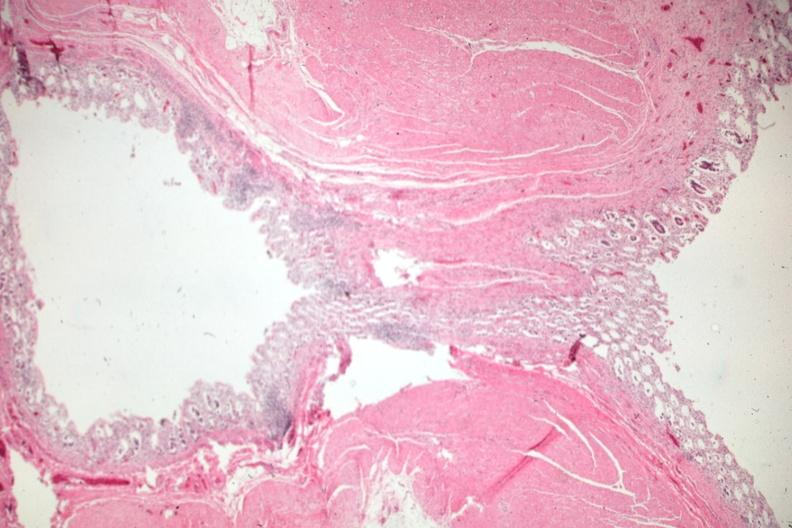what is present?
Answer the question using a single word or phrase. Colon 